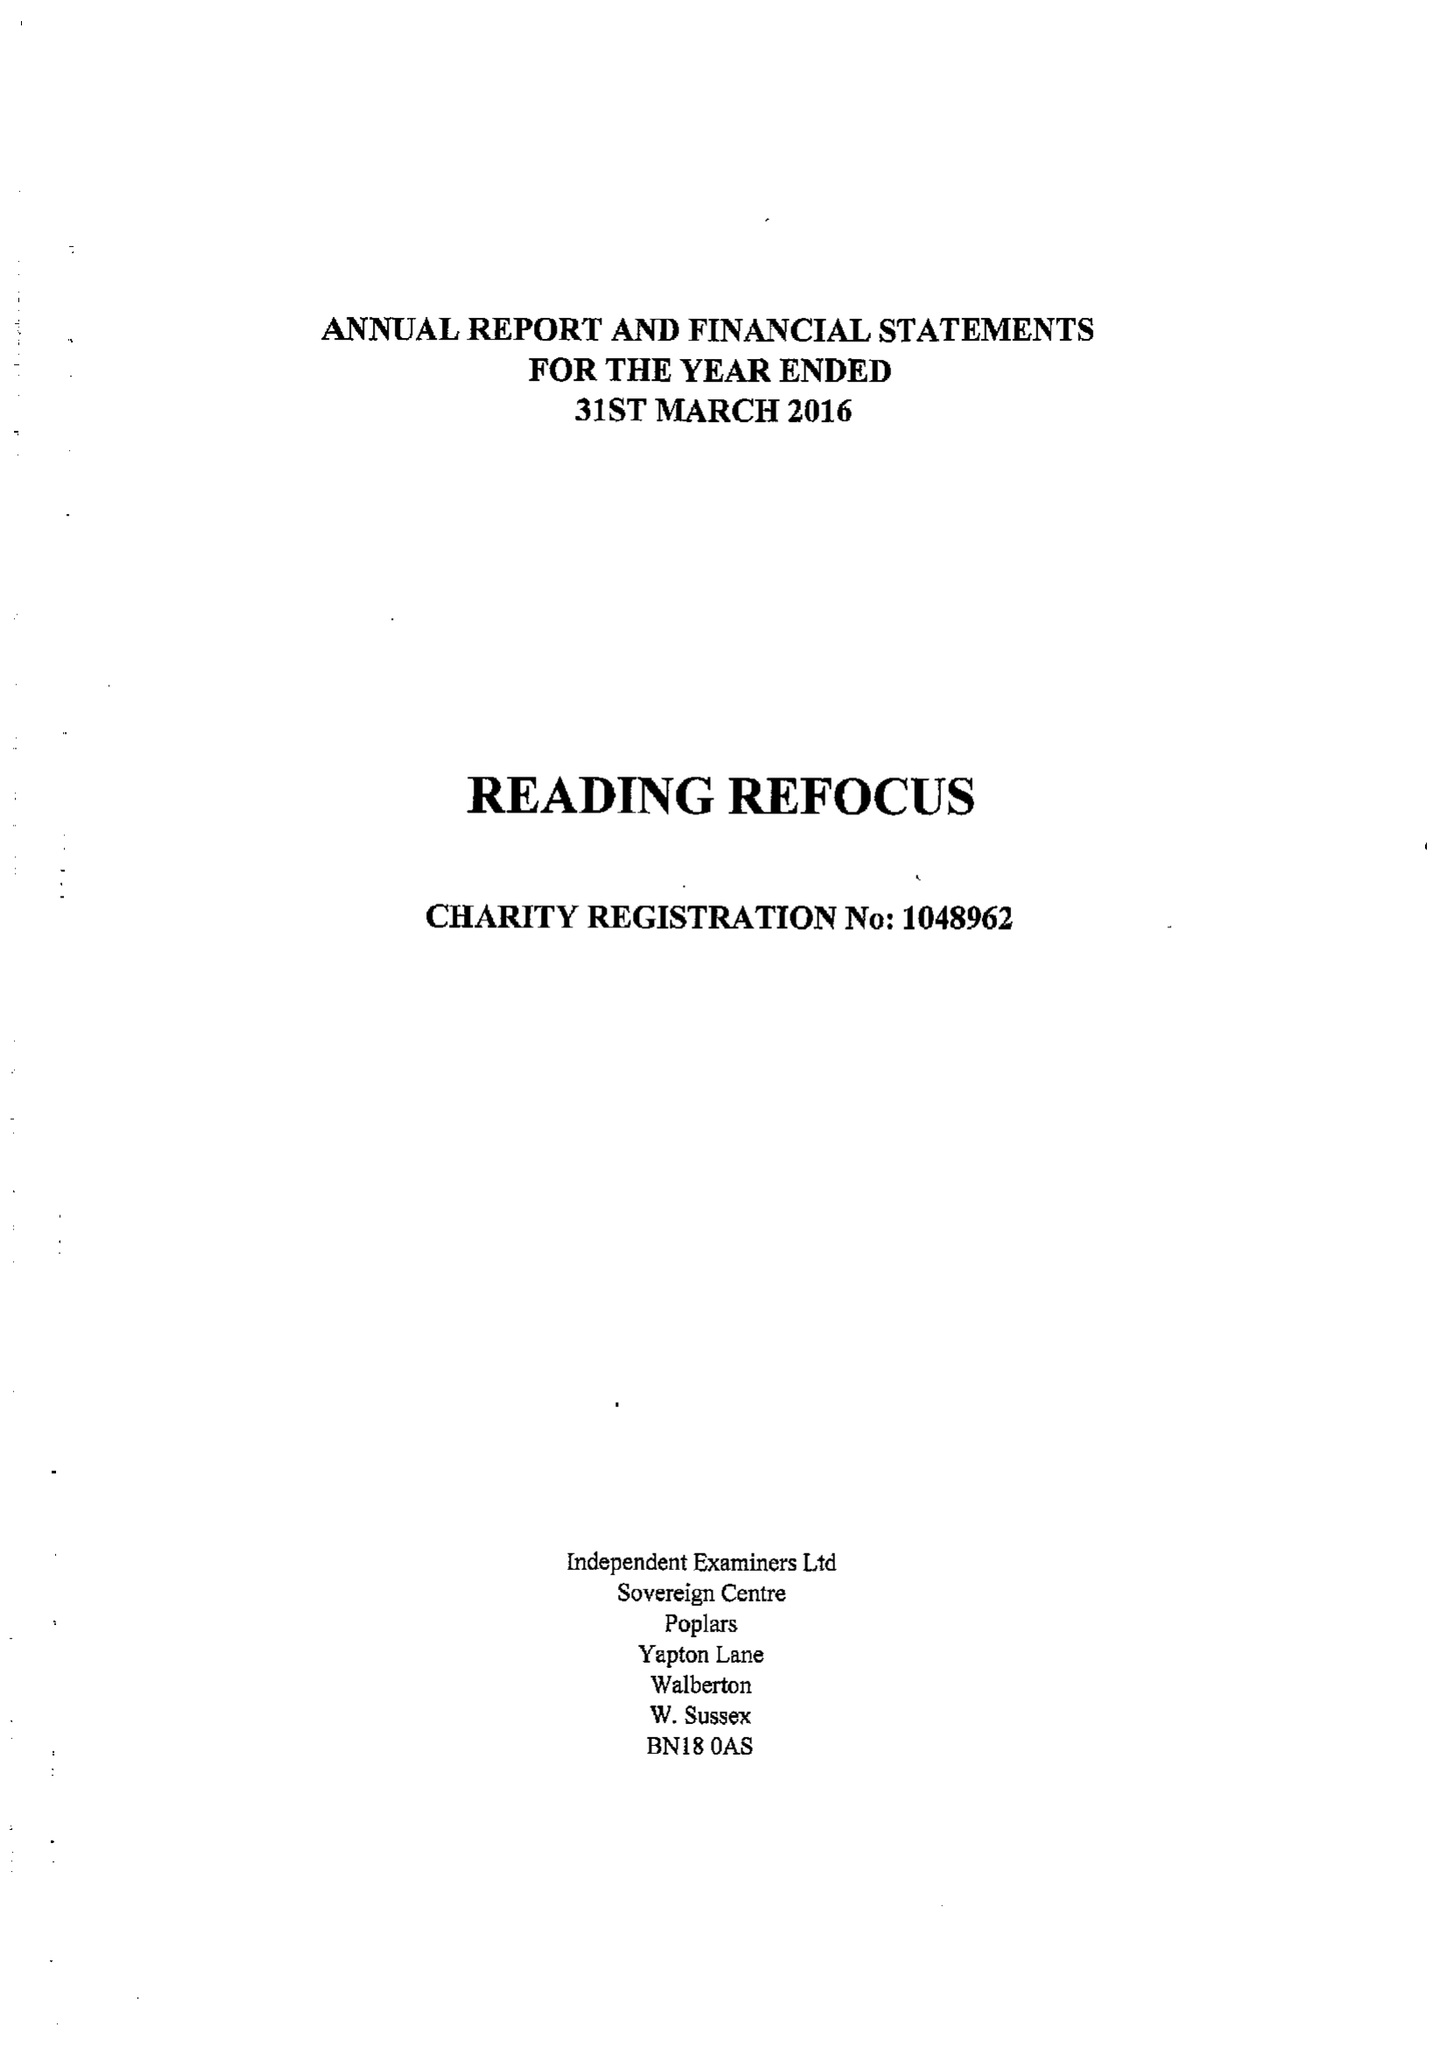What is the value for the spending_annually_in_british_pounds?
Answer the question using a single word or phrase. 28881.00 